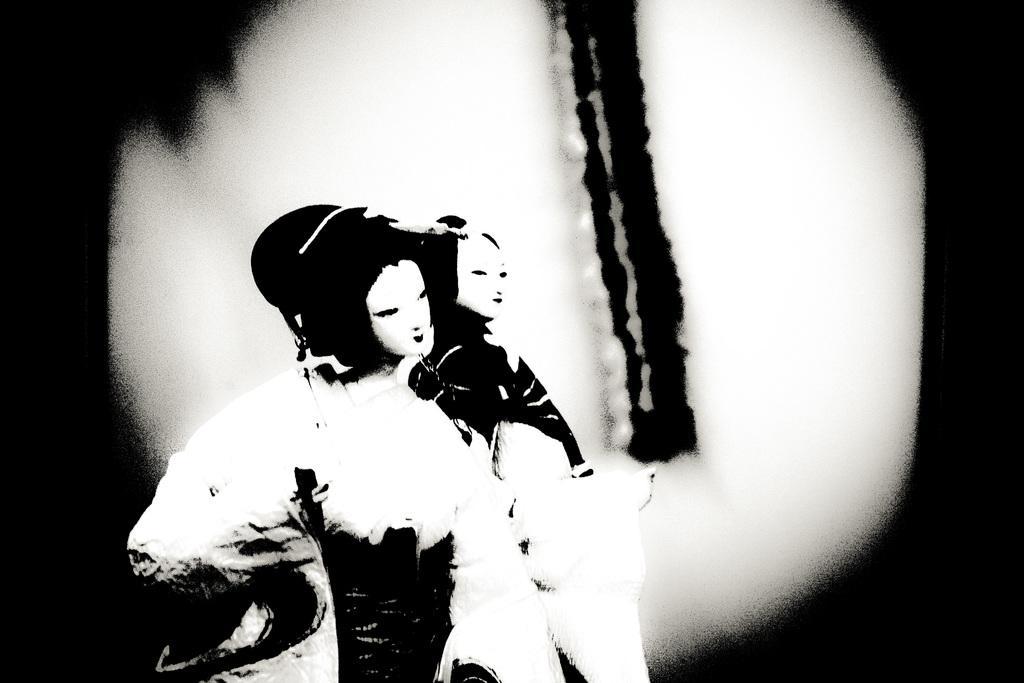Describe this image in one or two sentences. Here this picture looks like an edited image and in the middle of it we can see two persons standing and both of them are wearing face masks on them over there. 